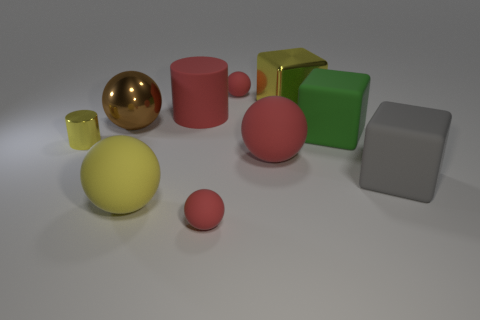Which objects in the image have reflective surfaces? The image showcases two objects with notably reflective surfaces: a large golden sphere and a silver cube. Their surfaces reflect the environment and light, giving them a shiny appearance. Could you explain how these reflections contribute to the overall perception of the image? The reflections on the golden sphere and silver cube add depth and realism to the image. They create a contrast between the matte and shiny surfaces, making the composition more dynamic and visually appealing. The reflective surfaces also hint at the nature of the environment surrounding the objects, suggesting a spacious and lightly colored setting. 